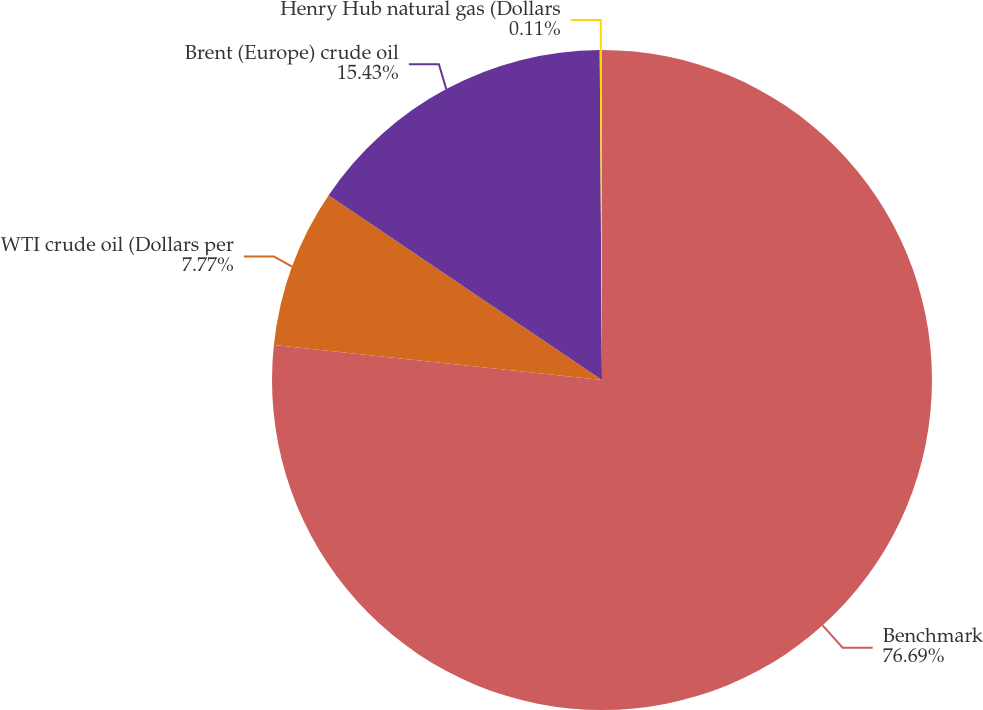Convert chart to OTSL. <chart><loc_0><loc_0><loc_500><loc_500><pie_chart><fcel>Benchmark<fcel>WTI crude oil (Dollars per<fcel>Brent (Europe) crude oil<fcel>Henry Hub natural gas (Dollars<nl><fcel>76.7%<fcel>7.77%<fcel>15.43%<fcel>0.11%<nl></chart> 